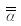Convert formula to latex. <formula><loc_0><loc_0><loc_500><loc_500>\overline { \overline { \alpha } }</formula> 